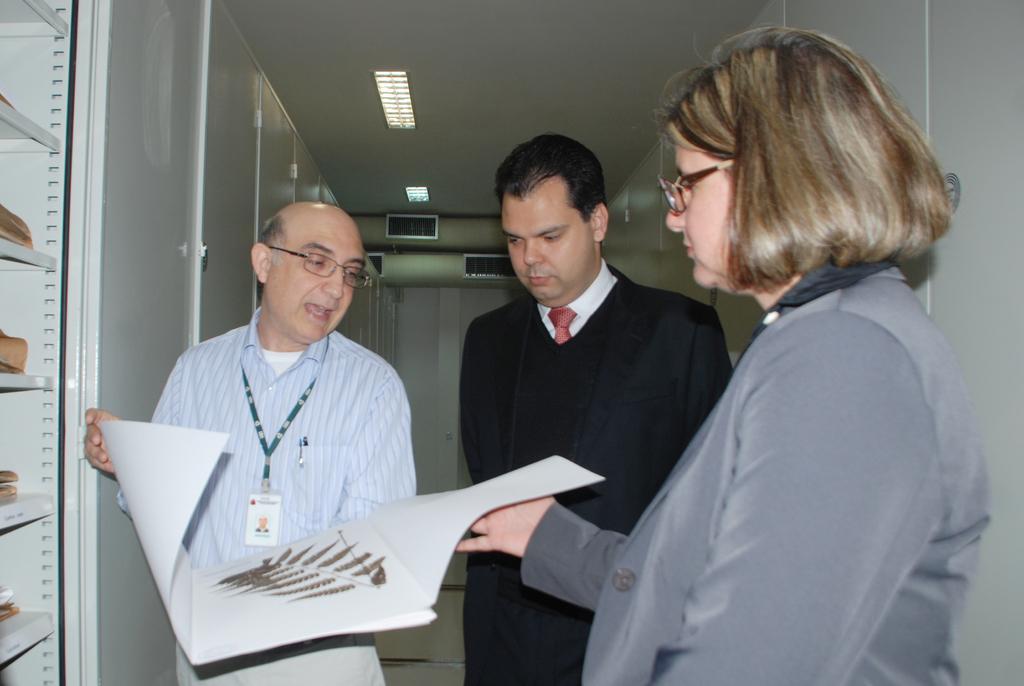Could you give a brief overview of what you see in this image? This image is taken indoors. At the top of the image there is a roof with two lights. In the background there is a wall and there is an air conditioner. On the left side of the image there is a cupboard with a few shelves and there are a few things on the shelves. There are many cupboards with doors. In the middle of the image two men and a woman are standing on the floor. A man and a woman are holding a book in their hands. 